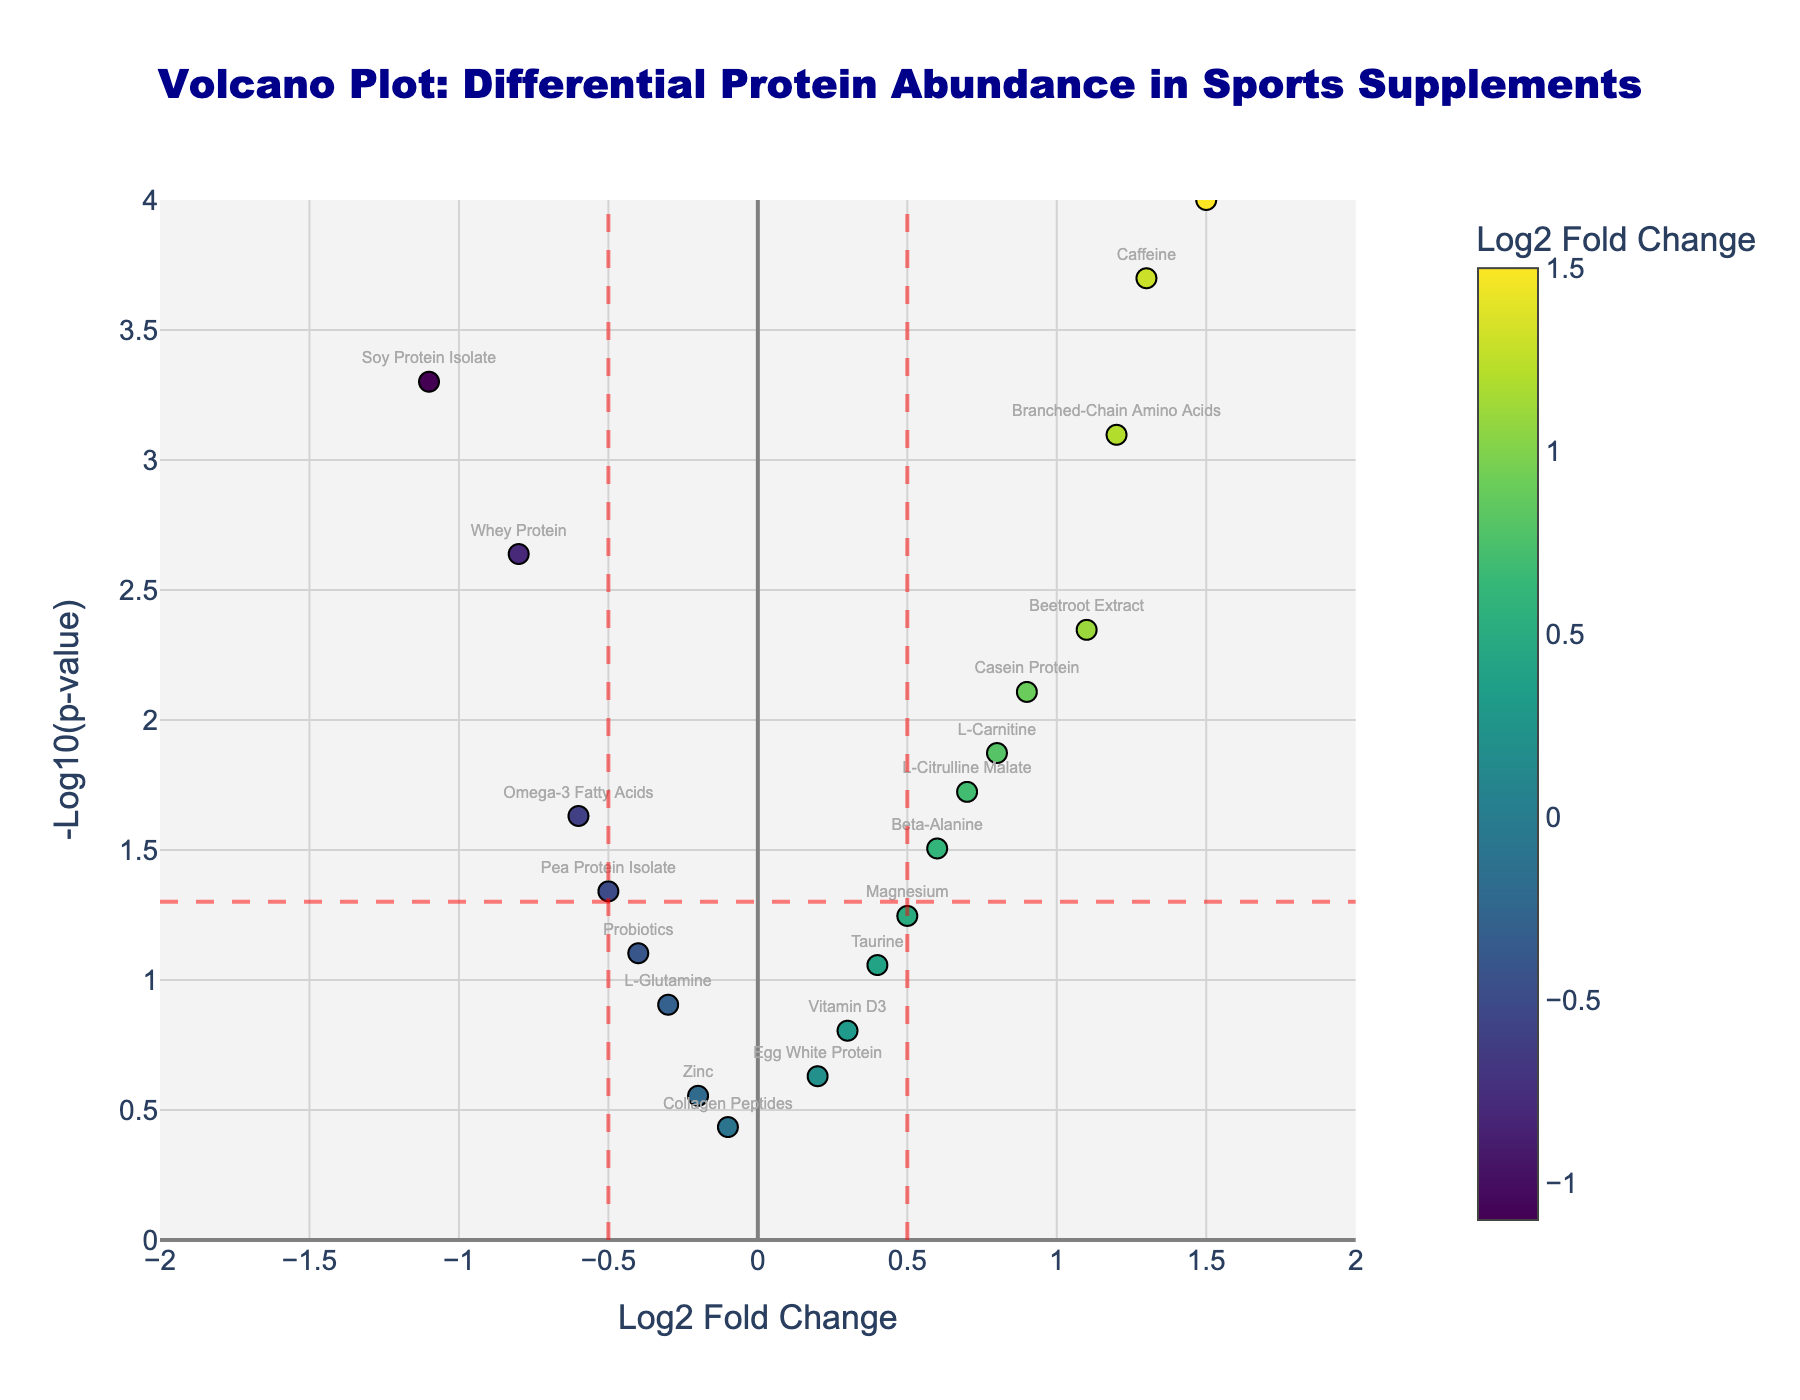1. What is the title of the plot? The title is located at the top of the figure and is used to describe the content or purpose of the plot. The text clearly explains what the plot is about.
Answer: Volcano Plot: Differential Protein Abundance in Sports Supplements 2. How many data points are shown in the plot? By counting the number of markers or points in the figure, you can determine the total number of data points represented. Each represents a specific protein.
Answer: 19 3. Which protein has the highest -log10(p-value)? We look for the protein that has the highest y-axis value, representing the highest -log10(p-value). This is visually identifiable as the highest point on the plot.
Answer: Creatine Monohydrate 4. What color is used to represent the Log2 Fold Change, and how does it vary? The color of the markers in the plot is used to represent the Log2 Fold Change of the proteins. The colors range across a spectrum, with a legend indicating this variation.
Answer: Colors range from light to dark along a colorscale (Viridis) 5. What protein has the most negative Log2 Fold Change? Find the marker that is furthest to the left on the x-axis, as this represents the lowest (most negative) Log2 Fold Change.
Answer: Soy Protein Isolate 6. Which proteins have a p-value greater than 0.05? Proteins with p-values greater than 0.05 are above the horizontal red dashed line on the plot, as -log10(p-value) for 0.05 is 1.30.
Answer: L-Glutamine, Egg White Protein, Collagen Peptides, Taurine, Vitamin D3, Zinc, Magnesium, Probiotics 7. Compare the Log2 Fold Change values of Beetroot Extract and Casein Protein? Which one is higher? Look at the x-axis values for both Beetroot Extract and Casein Protein to compare their Log2 Fold Change values.
Answer: Beetroot Extract 8. What is the significance threshold for p-values used in the plot, and how is it visually indicated? The plot uses a horizontal red dashed line to indicate the significance threshold for p-values, marked by -log10(p-value) for a chosen threshold.
Answer: 0.05 9. Which proteins have a Log2 Fold Change between -0.5 and 0.5 and are statistically significant (p-value < 0.05)? Identify proteins within the range of -0.5 to 0.5 on the x-axis and below the -log10(p-value) of 1.30 (p < 0.05) on the y-axis.
Answer: Whey Protein, L-Carnitine, L-Citrulline Malate 10. Which protein is closest to the threshold boundary of Log2 Fold Change at -0.5? Identify the protein marker closest to the vertical red dashed line at -0.5 Log2 Fold Change. This involves visually comparing the distances to this line.
Answer: Whey Protein 